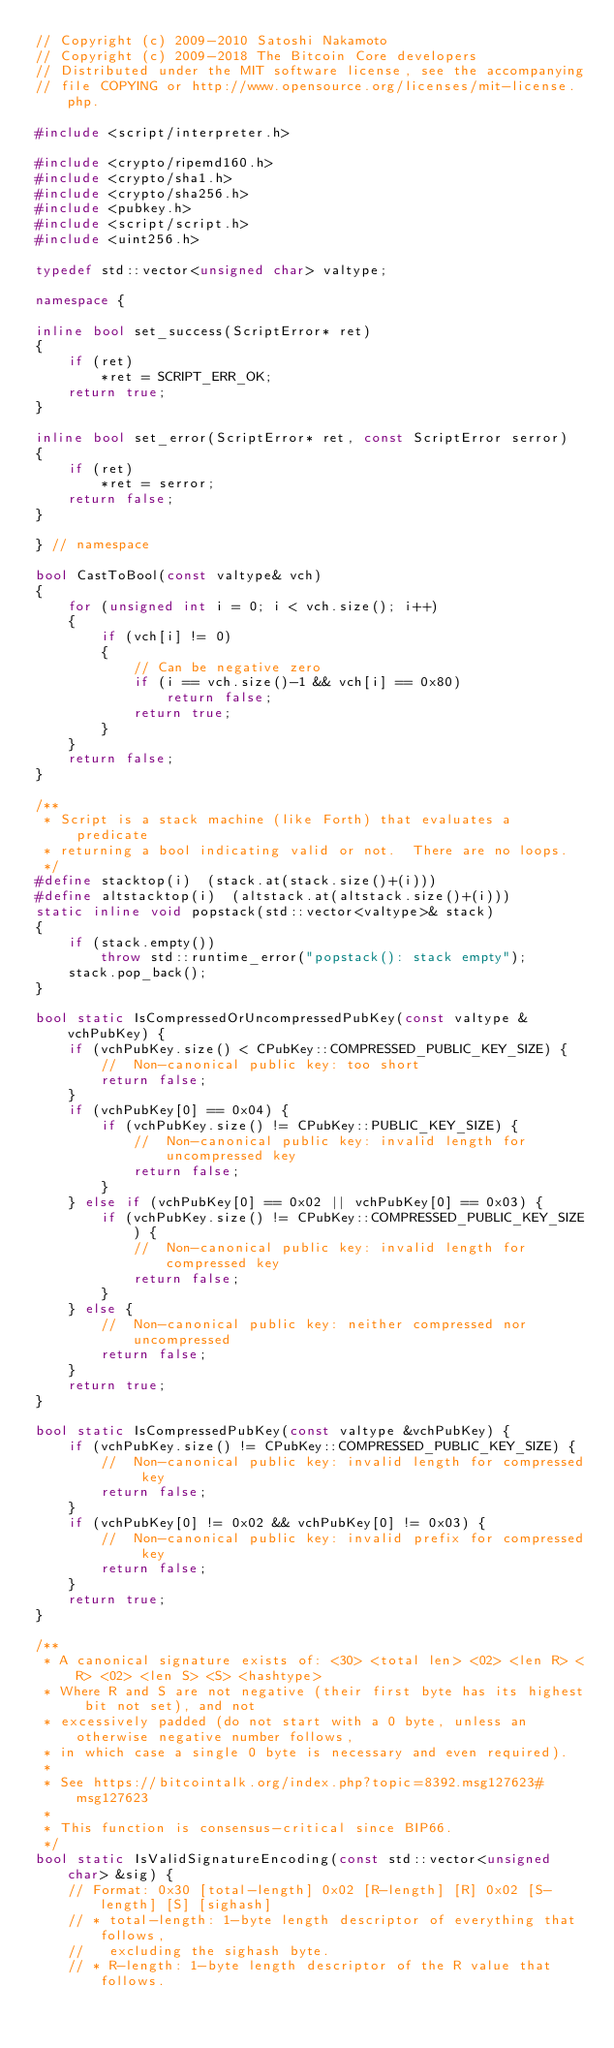<code> <loc_0><loc_0><loc_500><loc_500><_C++_>// Copyright (c) 2009-2010 Satoshi Nakamoto
// Copyright (c) 2009-2018 The Bitcoin Core developers
// Distributed under the MIT software license, see the accompanying
// file COPYING or http://www.opensource.org/licenses/mit-license.php.

#include <script/interpreter.h>

#include <crypto/ripemd160.h>
#include <crypto/sha1.h>
#include <crypto/sha256.h>
#include <pubkey.h>
#include <script/script.h>
#include <uint256.h>

typedef std::vector<unsigned char> valtype;

namespace {

inline bool set_success(ScriptError* ret)
{
    if (ret)
        *ret = SCRIPT_ERR_OK;
    return true;
}

inline bool set_error(ScriptError* ret, const ScriptError serror)
{
    if (ret)
        *ret = serror;
    return false;
}

} // namespace

bool CastToBool(const valtype& vch)
{
    for (unsigned int i = 0; i < vch.size(); i++)
    {
        if (vch[i] != 0)
        {
            // Can be negative zero
            if (i == vch.size()-1 && vch[i] == 0x80)
                return false;
            return true;
        }
    }
    return false;
}

/**
 * Script is a stack machine (like Forth) that evaluates a predicate
 * returning a bool indicating valid or not.  There are no loops.
 */
#define stacktop(i)  (stack.at(stack.size()+(i)))
#define altstacktop(i)  (altstack.at(altstack.size()+(i)))
static inline void popstack(std::vector<valtype>& stack)
{
    if (stack.empty())
        throw std::runtime_error("popstack(): stack empty");
    stack.pop_back();
}

bool static IsCompressedOrUncompressedPubKey(const valtype &vchPubKey) {
    if (vchPubKey.size() < CPubKey::COMPRESSED_PUBLIC_KEY_SIZE) {
        //  Non-canonical public key: too short
        return false;
    }
    if (vchPubKey[0] == 0x04) {
        if (vchPubKey.size() != CPubKey::PUBLIC_KEY_SIZE) {
            //  Non-canonical public key: invalid length for uncompressed key
            return false;
        }
    } else if (vchPubKey[0] == 0x02 || vchPubKey[0] == 0x03) {
        if (vchPubKey.size() != CPubKey::COMPRESSED_PUBLIC_KEY_SIZE) {
            //  Non-canonical public key: invalid length for compressed key
            return false;
        }
    } else {
        //  Non-canonical public key: neither compressed nor uncompressed
        return false;
    }
    return true;
}

bool static IsCompressedPubKey(const valtype &vchPubKey) {
    if (vchPubKey.size() != CPubKey::COMPRESSED_PUBLIC_KEY_SIZE) {
        //  Non-canonical public key: invalid length for compressed key
        return false;
    }
    if (vchPubKey[0] != 0x02 && vchPubKey[0] != 0x03) {
        //  Non-canonical public key: invalid prefix for compressed key
        return false;
    }
    return true;
}

/**
 * A canonical signature exists of: <30> <total len> <02> <len R> <R> <02> <len S> <S> <hashtype>
 * Where R and S are not negative (their first byte has its highest bit not set), and not
 * excessively padded (do not start with a 0 byte, unless an otherwise negative number follows,
 * in which case a single 0 byte is necessary and even required).
 *
 * See https://bitcointalk.org/index.php?topic=8392.msg127623#msg127623
 *
 * This function is consensus-critical since BIP66.
 */
bool static IsValidSignatureEncoding(const std::vector<unsigned char> &sig) {
    // Format: 0x30 [total-length] 0x02 [R-length] [R] 0x02 [S-length] [S] [sighash]
    // * total-length: 1-byte length descriptor of everything that follows,
    //   excluding the sighash byte.
    // * R-length: 1-byte length descriptor of the R value that follows.</code> 